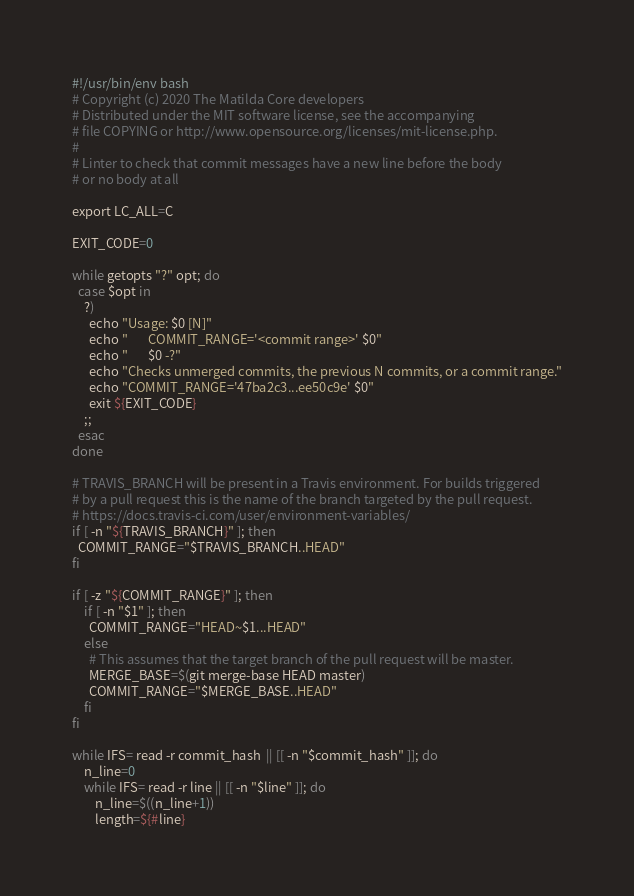Convert code to text. <code><loc_0><loc_0><loc_500><loc_500><_Bash_>#!/usr/bin/env bash
# Copyright (c) 2020 The Matilda Core developers
# Distributed under the MIT software license, see the accompanying
# file COPYING or http://www.opensource.org/licenses/mit-license.php.
#
# Linter to check that commit messages have a new line before the body
# or no body at all

export LC_ALL=C

EXIT_CODE=0

while getopts "?" opt; do
  case $opt in
    ?)
      echo "Usage: $0 [N]"
      echo "       COMMIT_RANGE='<commit range>' $0"
      echo "       $0 -?"
      echo "Checks unmerged commits, the previous N commits, or a commit range."
      echo "COMMIT_RANGE='47ba2c3...ee50c9e' $0"
      exit ${EXIT_CODE}
    ;;
  esac
done

# TRAVIS_BRANCH will be present in a Travis environment. For builds triggered
# by a pull request this is the name of the branch targeted by the pull request.
# https://docs.travis-ci.com/user/environment-variables/
if [ -n "${TRAVIS_BRANCH}" ]; then
  COMMIT_RANGE="$TRAVIS_BRANCH..HEAD"
fi

if [ -z "${COMMIT_RANGE}" ]; then
    if [ -n "$1" ]; then
      COMMIT_RANGE="HEAD~$1...HEAD"
    else
      # This assumes that the target branch of the pull request will be master.
      MERGE_BASE=$(git merge-base HEAD master)
      COMMIT_RANGE="$MERGE_BASE..HEAD"
    fi
fi

while IFS= read -r commit_hash  || [[ -n "$commit_hash" ]]; do
    n_line=0
    while IFS= read -r line || [[ -n "$line" ]]; do
        n_line=$((n_line+1))
        length=${#line}</code> 